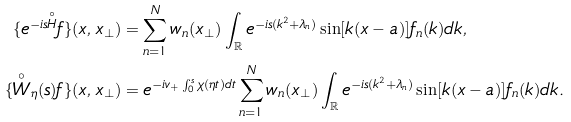Convert formula to latex. <formula><loc_0><loc_0><loc_500><loc_500>\{ e ^ { - i s \overset { \circ } { H } } f \} ( x , { x } _ { \perp } ) & = \sum _ { n = 1 } ^ { N } w _ { n } ( { x } _ { \perp } ) \int _ { \mathbb { R } } e ^ { - i s ( k ^ { 2 } + \lambda _ { n } ) } \sin [ k ( x - a ) ] f _ { n } ( k ) d k , \\ \{ \overset { \circ } { W } _ { \eta } ( s ) f \} ( x , { x } _ { \perp } ) & = e ^ { - i v _ { + } \int _ { 0 } ^ { s } \chi ( \eta t ) d t } \sum _ { n = 1 } ^ { N } w _ { n } ( { x } _ { \perp } ) \int _ { \mathbb { R } } e ^ { - i s ( k ^ { 2 } + \lambda _ { n } ) } \sin [ k ( x - a ) ] f _ { n } ( k ) d k .</formula> 